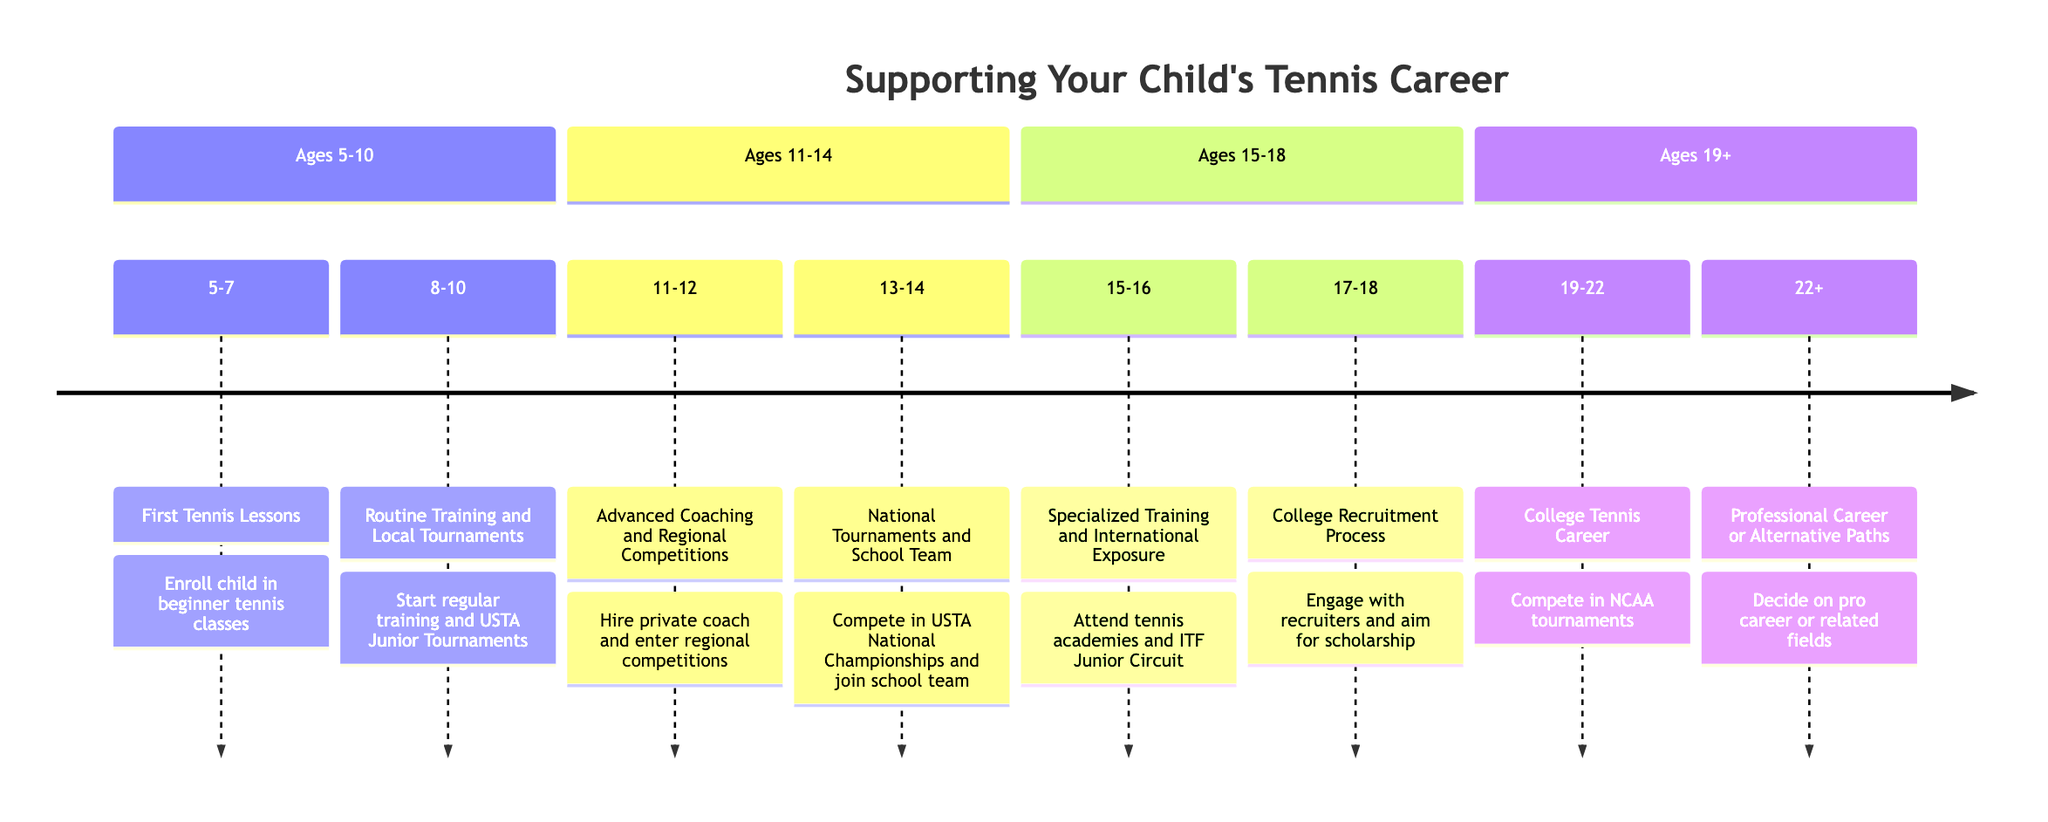What is the first milestone in a child's tennis career? The first milestone is "First Tennis Lessons." It is stated under the age range of 5-7 in the timeline.
Answer: First Tennis Lessons At what age do children typically begin to participate in local tournaments? Children typically begin participating in local tournaments at ages 8-10, as noted in the timeline with the milestone "Routine Training and Local Tournaments."
Answer: Ages 8-10 What event is associated with the milestone for ages 15-16? The event associated with the milestone for ages 15-16 is "Attend specialized tennis academies and participate in international tournaments like the ITF Junior Circuit." This event shows the progression to a higher level of competition.
Answer: Attend specialized tennis academies and participate in international tournaments What is the primary focus during the ages 17-18? The primary focus during the ages 17-18 is on the "College Recruitment Process." The timeline shows that this age is dedicated to engaging with college recruiters and finalizing college tennis placements.
Answer: College Recruitment Process How many key milestones are there in total from ages 5 to 22+? There are a total of eight key milestones outlined in the timeline, specified for different age ranges from 5 to 22+. Counting each milestone from the data confirms this total.
Answer: Eight What support element emphasizes health and fitness? The support element that emphasizes health and fitness is "Health And Fitness." This aspect covers the importance of balanced nutrition, exercise, and mental health.
Answer: Health And Fitness Which milestone occurs just before the decision for a professional career? The milestone that occurs just before the decision for a professional career, listed in the timeline, is "College Tennis Career," which spans from ages 19-22.
Answer: College Tennis Career What event takes place during the ages of 11-12? The event that takes place during the ages of 11-12 is "Hire a private coach and enter regional competitions." This indicates a transition to more serious training and competition.
Answer: Hire a private coach and enter regional competitions 